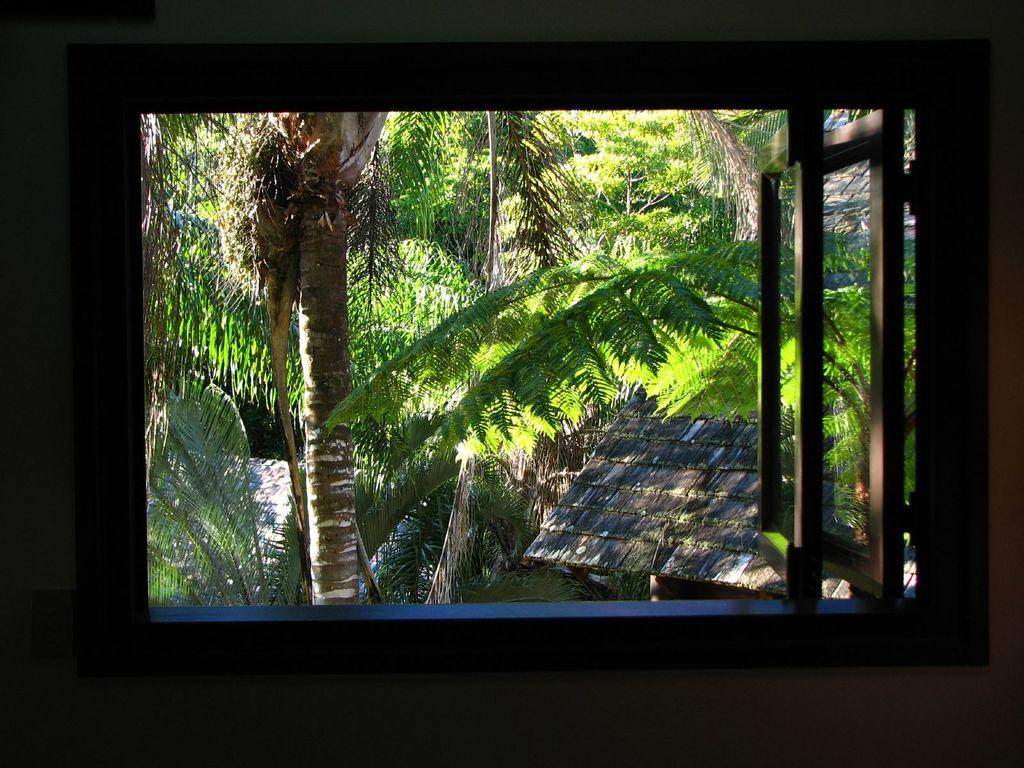What type of window is visible in the image? There is a wooden window in the image. What can be seen in the background of the image? There are trees in the background of the image. What committee is meeting in the image? There is no committee meeting in the image; it only features a wooden window and trees in the background. 